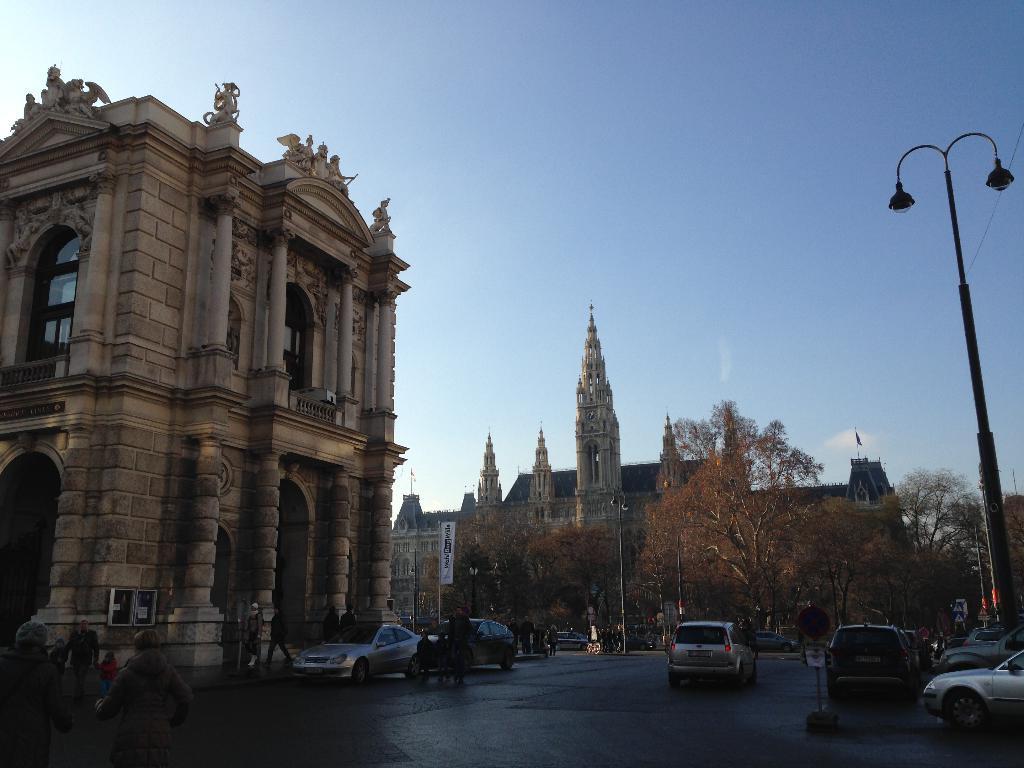In one or two sentences, can you explain what this image depicts? This image is taken outdoors. At the bottom of the image there is a road. At the top of the image there is a sky. In the middle of the image a few cars are parked on the road and a few are moving on the road. A few people are standing on the road and a few are walking on the road. In the middle of the image there are a few buildings, towers and there are a few trees, poles and street lights. 